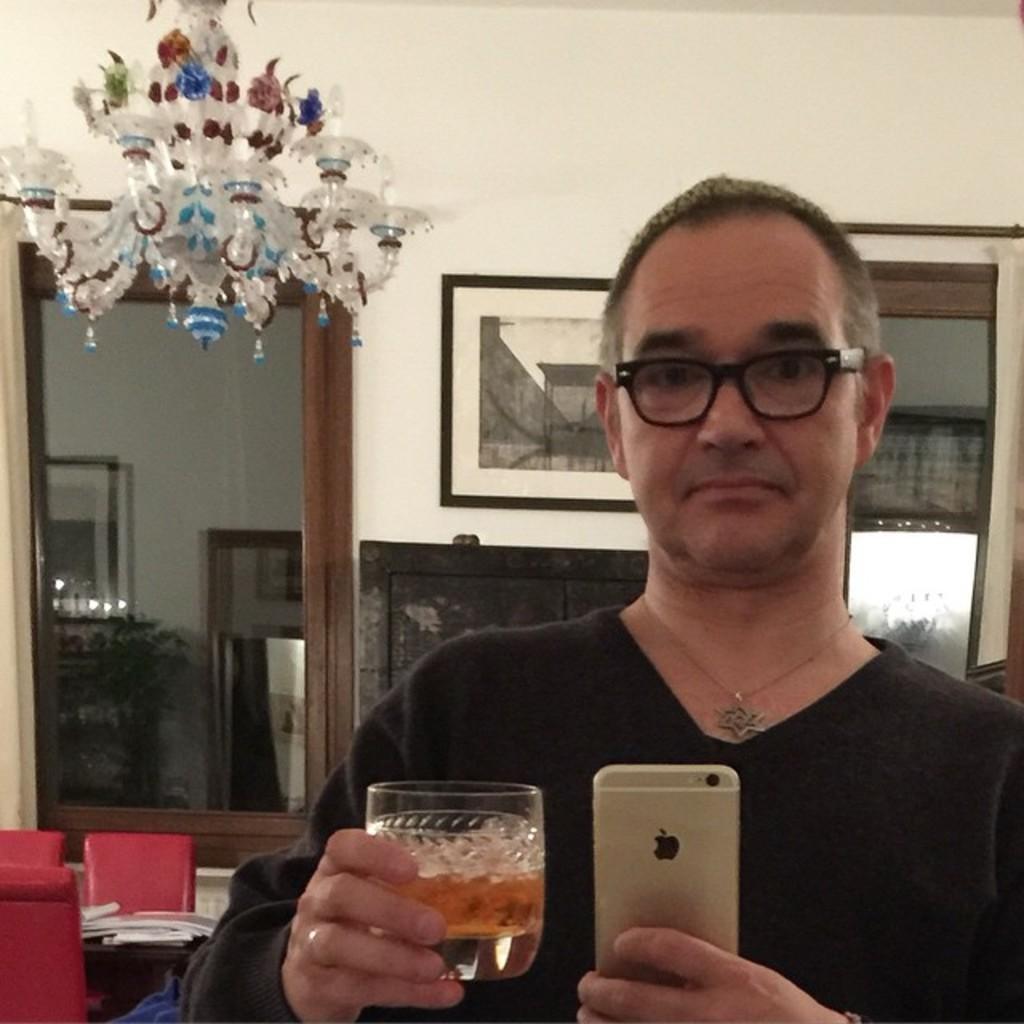How would you summarize this image in a sentence or two? In this picture there is a person, holding a glass and a phone, taking a picture of him. He is wearing spectacles. In the background there is chandelier. And there are photo frames attached to the wall. 